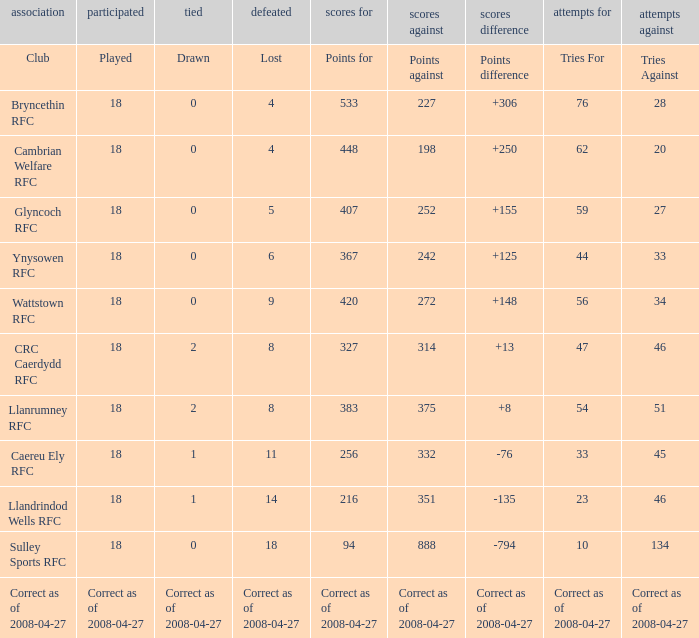What is the value of the item "Points" when the value of the item "Points against" is 272? 420.0. 